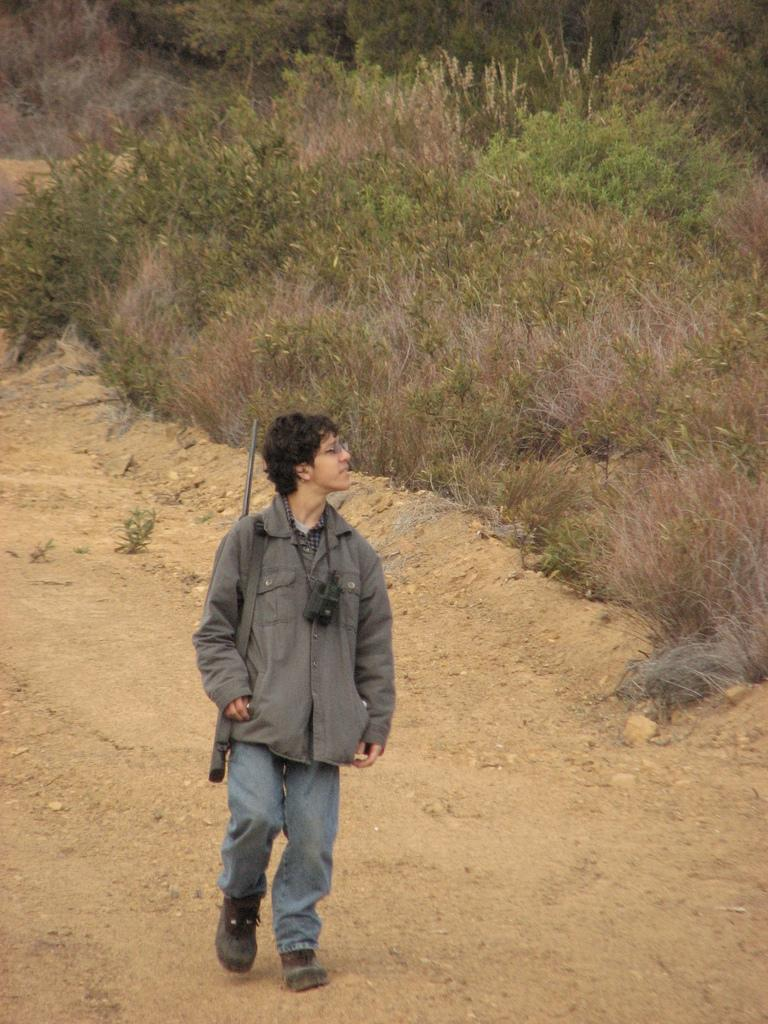What is the main subject of the image? There is a man in the image. What is the man doing in the image? The man is walking on the land. What type of clothing is the man wearing? The man is wearing a jacket and jeans. What items is the man carrying in the image? The man is carrying a gun and a camera. What can be seen in the background of the image? There is grass, plants, and trees in the background of the image. What type of skin can be seen on the man's face in the image? There is no specific detail about the man's skin visible in the image. How many pieces of lumber are visible in the image? There is no lumber present in the image. 